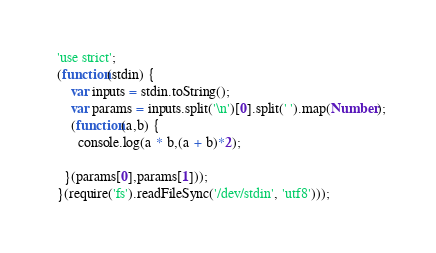Convert code to text. <code><loc_0><loc_0><loc_500><loc_500><_JavaScript_>  'use strict';
  (function(stdin) { 
      var inputs = stdin.toString();
      var params = inputs.split('\n')[0].split(' ').map(Number);
      (function(a,b) {
        console.log(a * b,(a + b)*2);

    }(params[0],params[1])); 
  }(require('fs').readFileSync('/dev/stdin', 'utf8')));</code> 